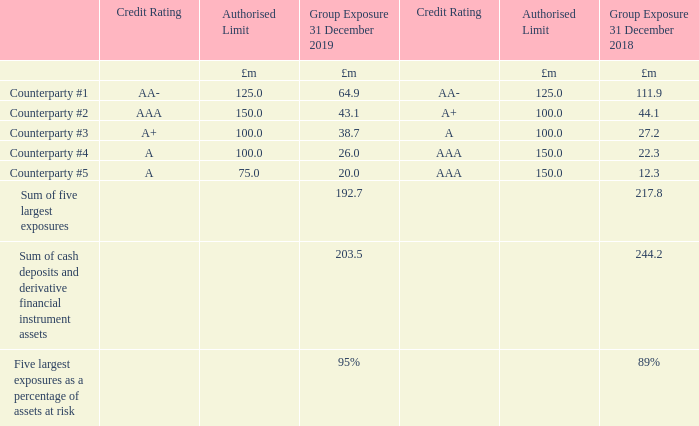At 31 December 2019 trade receivables are shown net of a loss allowance totalling £6.1 million (2018: £4.0 million).
The Group does not use factoring to generate cash flow from trade receivables.
– other financial assets including loans to joint ventures
The Group applies the expected credit loss model in respect of other financial assets. Financial assets are individually assessed as to whether the credit risk has increased significantly in the period and therefore whether there is a need to apply the lifetime expected credit losses model as opposed to the 12-month expected credit loss model.
At 31 December 2019 there is no loss allowance recognised for other financial assets as it has been concluded as an immaterial risk of credit loss on other financial assets.
– cash deposits and derivative financial instruments
The credit risk relating to cash deposits and derivative financial instruments is actively managed by the Group’s treasury department. Relationships are maintained with a number of tier one institutional counterparties, ensuring compliance with Group policy relating to limits on the credit ratings of counterparties (between BBB+ and AAA).
Excessive credit risk concentration is avoided through adhering to authorised limits for all counterparties.
What is the percentage of assets at risk in 2019? 95%. What is the sum of cash deposits and derivative financial instrument assets in 2018?
Answer scale should be: million. 244.2. Which model did the Group apply to assess credit risk of financial assets? Expected credit loss model. How many counterparties have authorised limit above 125.0 million in 2019? Counterparty #2
Answer: 1. What is the percentage of counterparty #5 exposure in the total exposure in 2019?
Answer scale should be: percent. 20.0/192.7
Answer: 10.38. What is the percentage change in the sum of cash deposits and derivative financial instrument assets from 2018 to 2019?
Answer scale should be: percent. (203.5-244.2)/244.2
Answer: -16.67. 